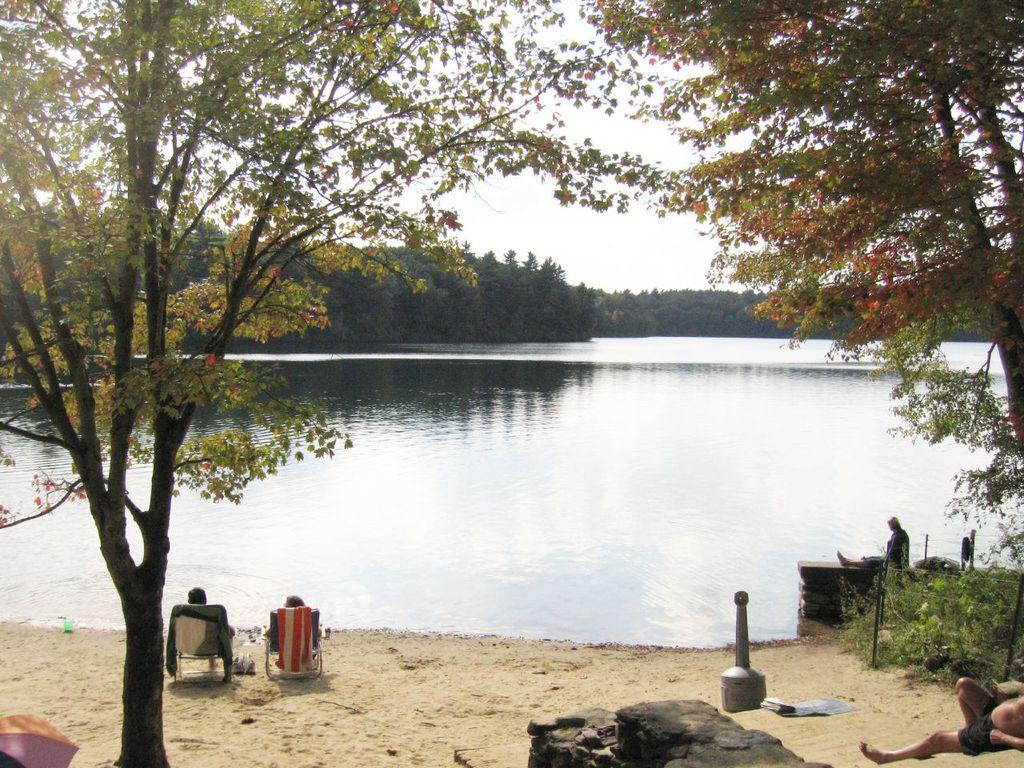How many persons are in the image? There are persons in the image. What are two of the persons doing in the image? Two of the persons are sitting on chairs. What items can be seen related to water activities? There are towels, an umbrella, and a river visible in the image. What type of vegetation is present in the image? There are trees and plants in the image. What part of the natural environment is visible in the image? The sky is visible in the image. What is the desire of the hands in the image? There are no hands mentioned in the image, so it is not possible to determine their desires. 